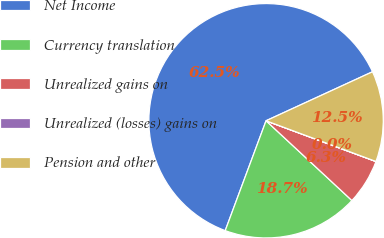Convert chart. <chart><loc_0><loc_0><loc_500><loc_500><pie_chart><fcel>Net Income<fcel>Currency translation<fcel>Unrealized gains on<fcel>Unrealized (losses) gains on<fcel>Pension and other<nl><fcel>62.47%<fcel>18.75%<fcel>6.26%<fcel>0.01%<fcel>12.51%<nl></chart> 